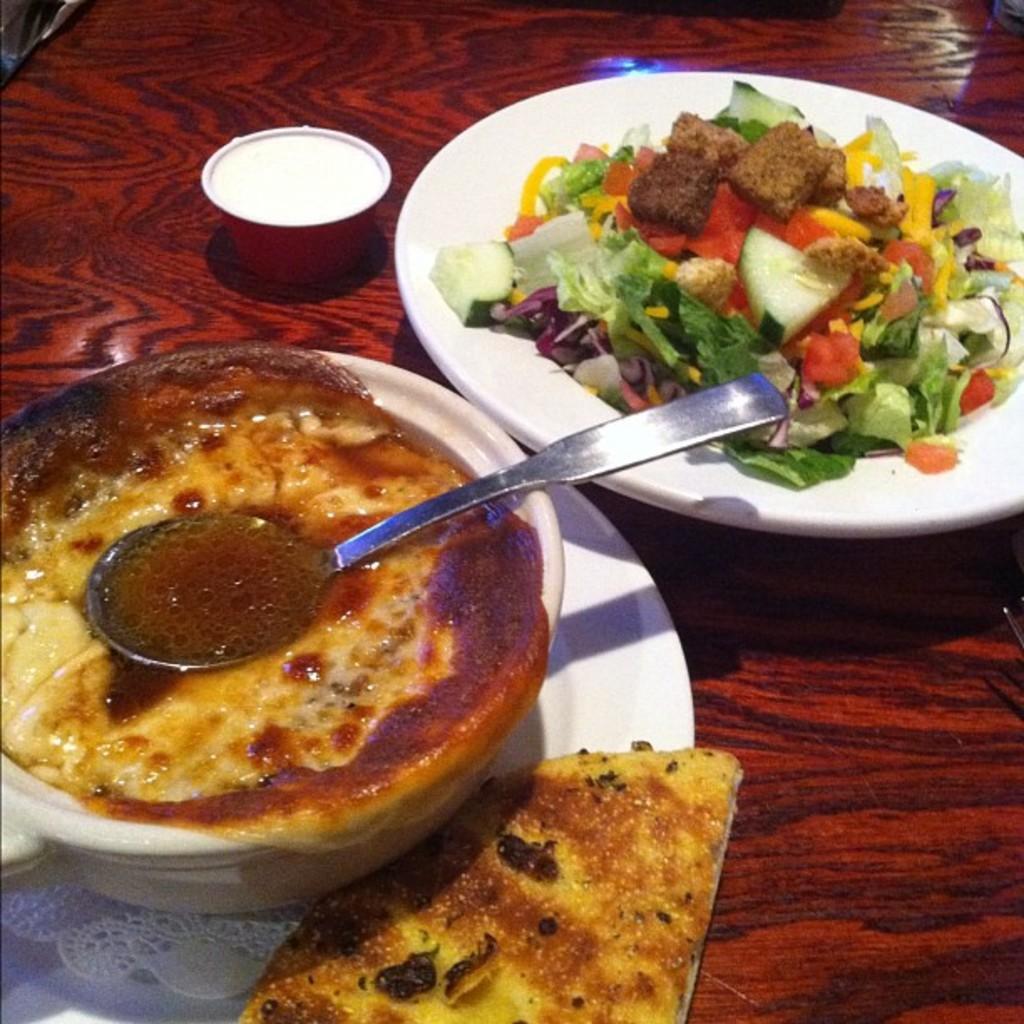Describe this image in one or two sentences. In this image I can see food items in a bowl and in a plate. I can also see a spoon and some other objects on a wooden surface. 